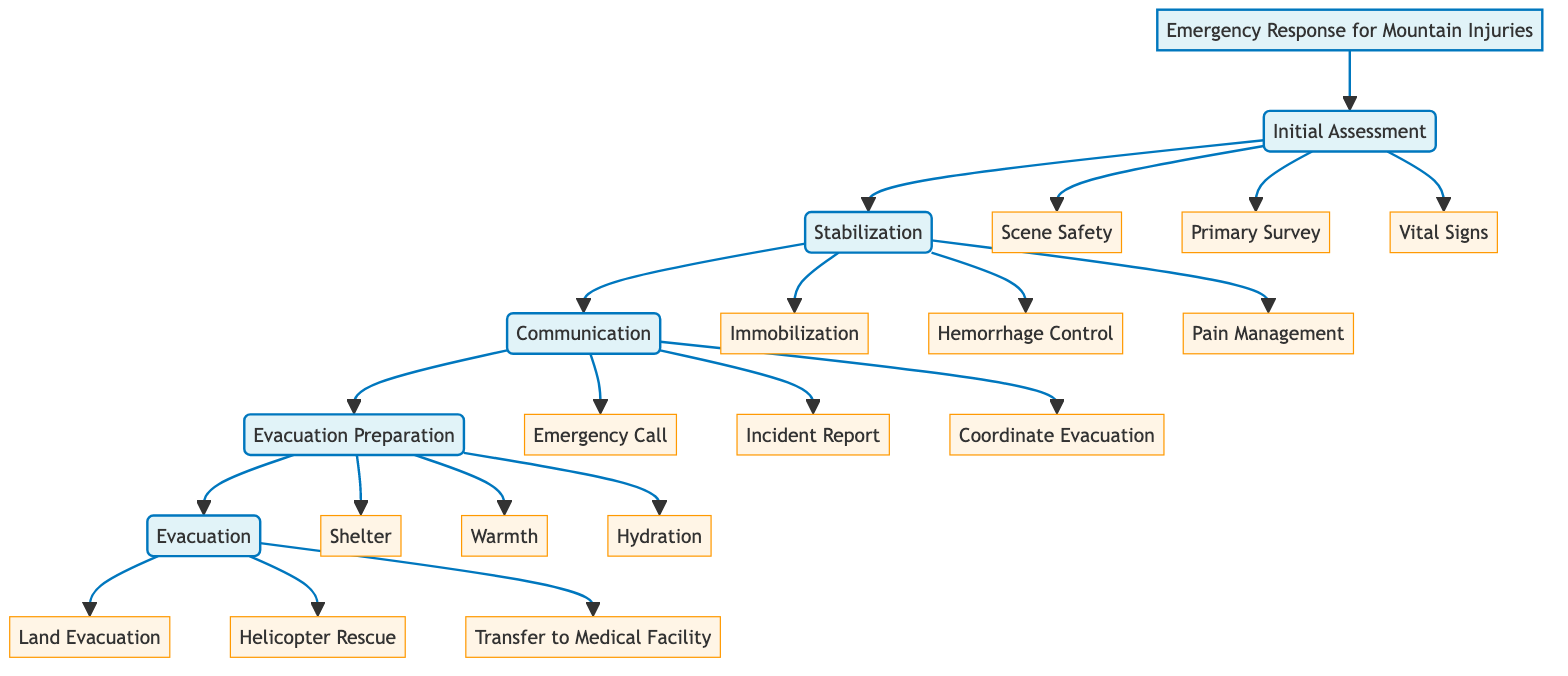What is the first step in the pathway? The first step listed in the diagram is "Initial Assessment," which comes directly after the title.
Answer: Initial Assessment How many substeps are there in "Stabilization"? In the diagram, "Stabilization" has three associated substeps: "Immobilization," "Hemorrhage Control," and "Pain Management."
Answer: 3 What action should be taken in the "Evacuation Preparation" step to ensure the injured person is warm? According to the diagram, the action to ensure warmth for the injured person is to use blankets or sleeping bags, which is explicitly stated in the "Warmth" substep.
Answer: Warmth What is required to manage pain according to the "Stabilization" step? The diagram specifies that pain management should include administering pain relief according to protocols, such as Ibuprofen or Acetaminophen, which fall under the "Pain Management" substep.
Answer: Pain relief In which step would you make an "Emergency Call"? The "Emergency Call" is a substep under the "Communication" step, as indicated in the pathway.
Answer: Communication How many total main steps are outlined in the pathway? There are five main steps in the pathway: "Initial Assessment," "Stabilization," "Communication," "Evacuation Preparation," and "Evacuation."
Answer: 5 What are the two methods of evacuation mentioned in this diagram? The diagram mentions "Land Evacuation" and "Helicopter Rescue" as the two methods for evacuating the injured person.
Answer: Land Evacuation and Helicopter Rescue What specific medical facility is the injured person transferred to? The diagram states that the injured person is transferred to "Providence Alaska Medical Center" for comprehensive care, which is specifically mentioned in the "Transfer to Medical Facility" substep.
Answer: Providence Alaska Medical Center What is the purpose of the "Incident Report" in the "Communication" step? The purpose of the "Incident Report" is to provide a detailed report that includes location, nature of injury, and patient condition, as stated in the pathway.
Answer: Detailed report 